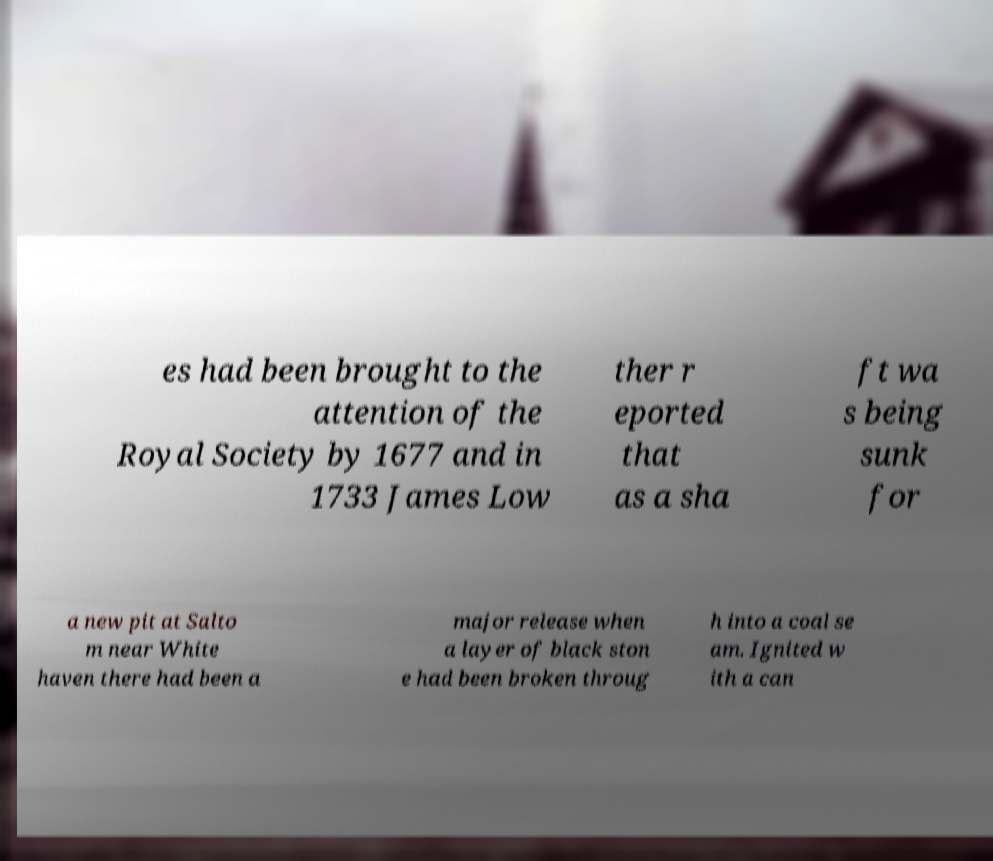Can you accurately transcribe the text from the provided image for me? es had been brought to the attention of the Royal Society by 1677 and in 1733 James Low ther r eported that as a sha ft wa s being sunk for a new pit at Salto m near White haven there had been a major release when a layer of black ston e had been broken throug h into a coal se am. Ignited w ith a can 